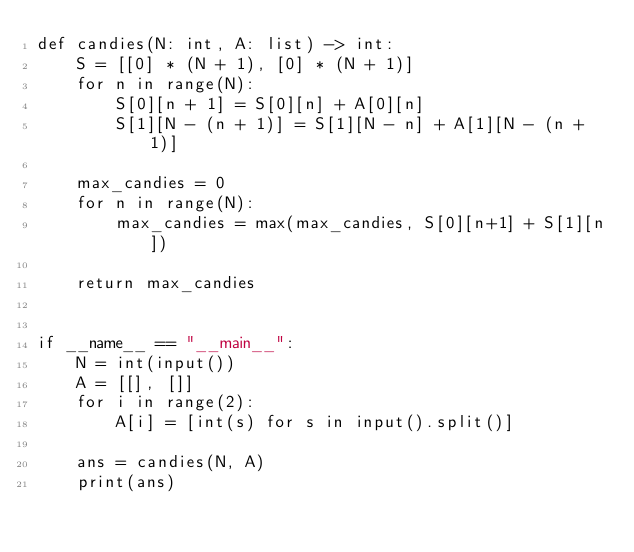Convert code to text. <code><loc_0><loc_0><loc_500><loc_500><_Python_>def candies(N: int, A: list) -> int:
    S = [[0] * (N + 1), [0] * (N + 1)]
    for n in range(N):
        S[0][n + 1] = S[0][n] + A[0][n]
        S[1][N - (n + 1)] = S[1][N - n] + A[1][N - (n + 1)]

    max_candies = 0
    for n in range(N):
        max_candies = max(max_candies, S[0][n+1] + S[1][n])

    return max_candies


if __name__ == "__main__":
    N = int(input())
    A = [[], []]
    for i in range(2):
        A[i] = [int(s) for s in input().split()]

    ans = candies(N, A)
    print(ans)
</code> 